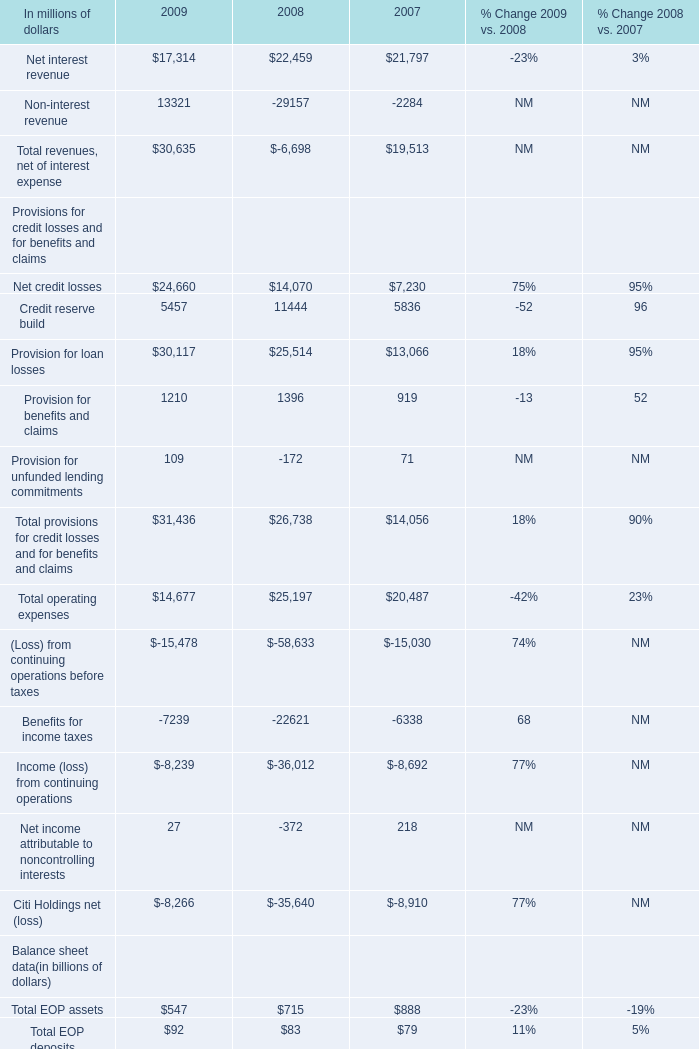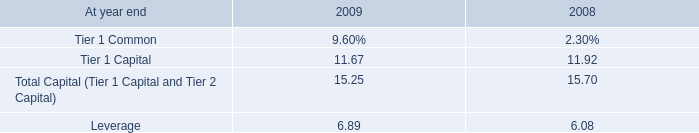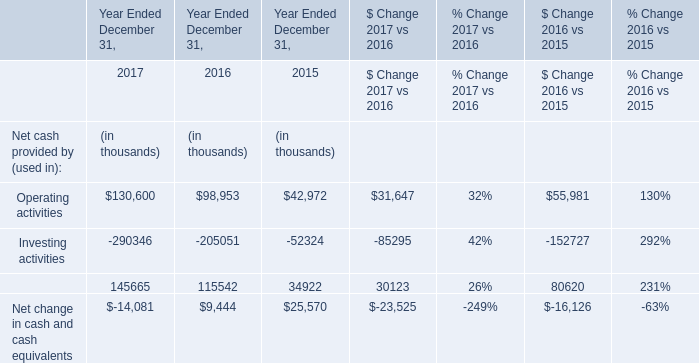In the year with the greatest proportion of Net interest revenue, what is the proportion of Net credit losses to the total? 
Computations: (14070 / ((24660 + 14070) + 7230))
Answer: 0.30614. 